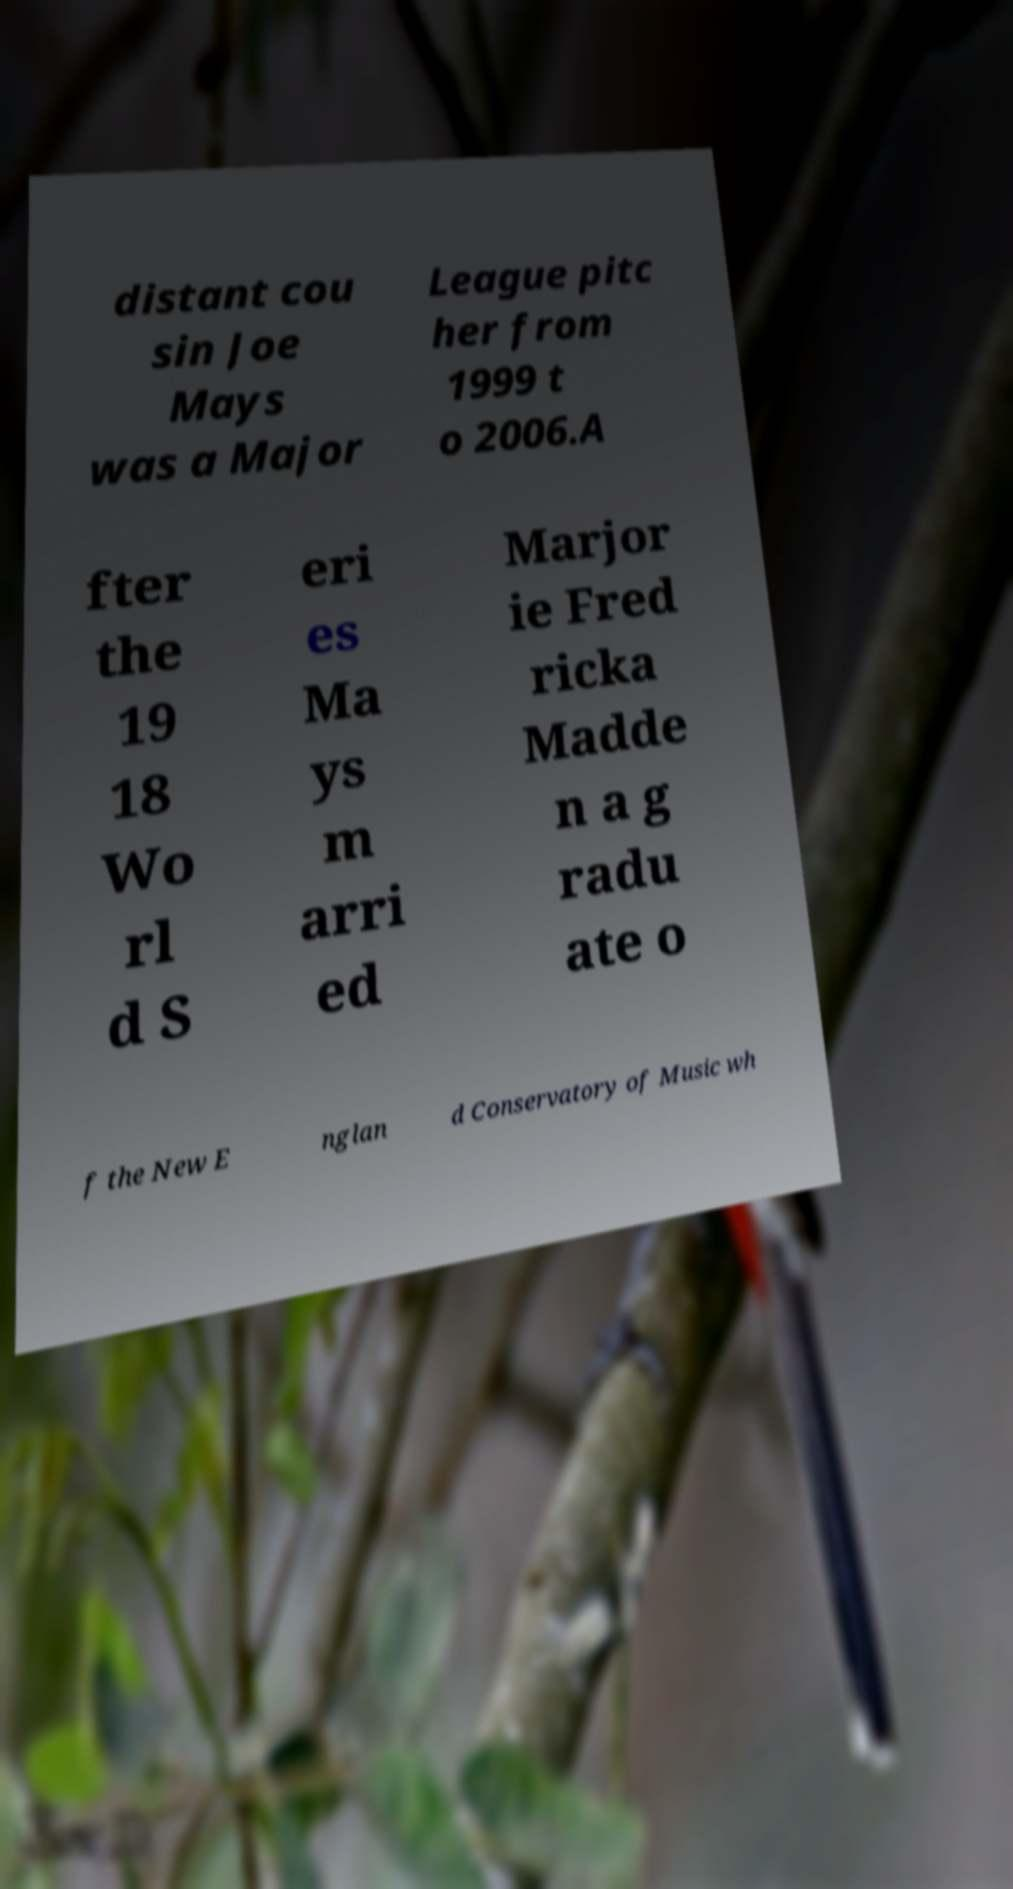Please read and relay the text visible in this image. What does it say? distant cou sin Joe Mays was a Major League pitc her from 1999 t o 2006.A fter the 19 18 Wo rl d S eri es Ma ys m arri ed Marjor ie Fred ricka Madde n a g radu ate o f the New E nglan d Conservatory of Music wh 